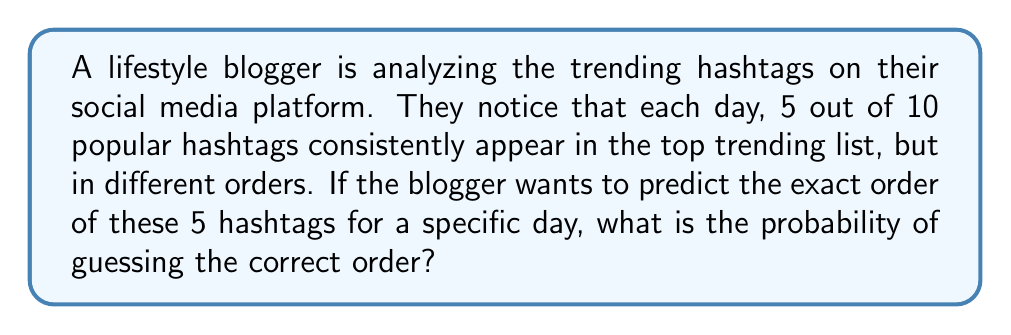Can you solve this math problem? To solve this problem, we need to consider the number of possible arrangements (permutations) of the 5 hashtags.

1) Since we are arranging all 5 hashtags in a specific order, and the order matters, this is a permutation problem.

2) The number of permutations of n distinct objects is given by:

   $$P(n) = n!$$

3) In this case, we have 5 hashtags, so n = 5.

4) Therefore, the number of possible arrangements is:

   $$P(5) = 5! = 5 \times 4 \times 3 \times 2 \times 1 = 120$$

5) The probability of guessing the correct order is 1 out of the total number of possible arrangements:

   $$P(\text{correct guess}) = \frac{1}{\text{number of arrangements}} = \frac{1}{120}$$

Thus, the probability of the lifestyle blogger correctly guessing the exact order of the 5 trending hashtags is $\frac{1}{120}$.
Answer: $\frac{1}{120}$ or approximately 0.00833 or 0.833% 